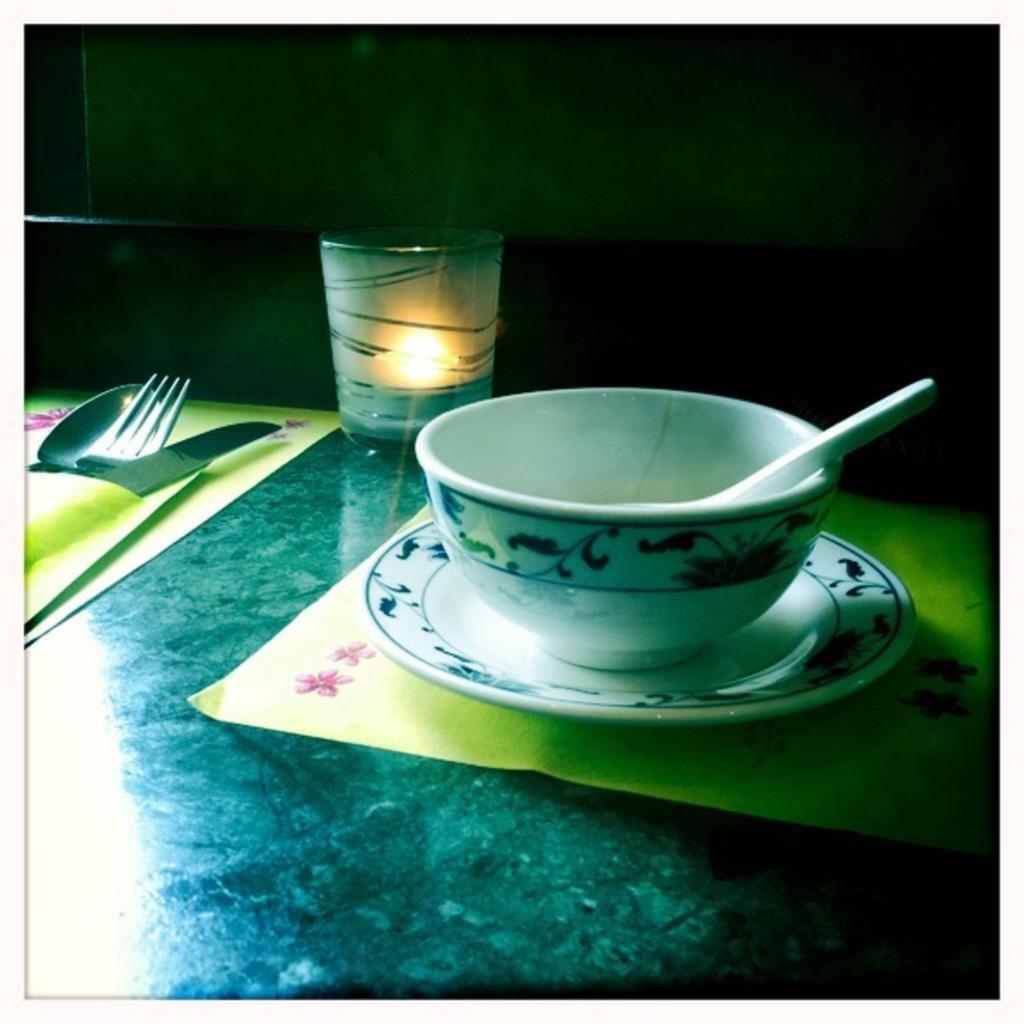Please provide a concise description of this image. A bowl,a candle and spoon,fork and knife are placed on a table. 